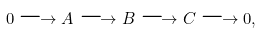<formula> <loc_0><loc_0><loc_500><loc_500>0 \longrightarrow A \longrightarrow B \longrightarrow C \longrightarrow 0 ,</formula> 